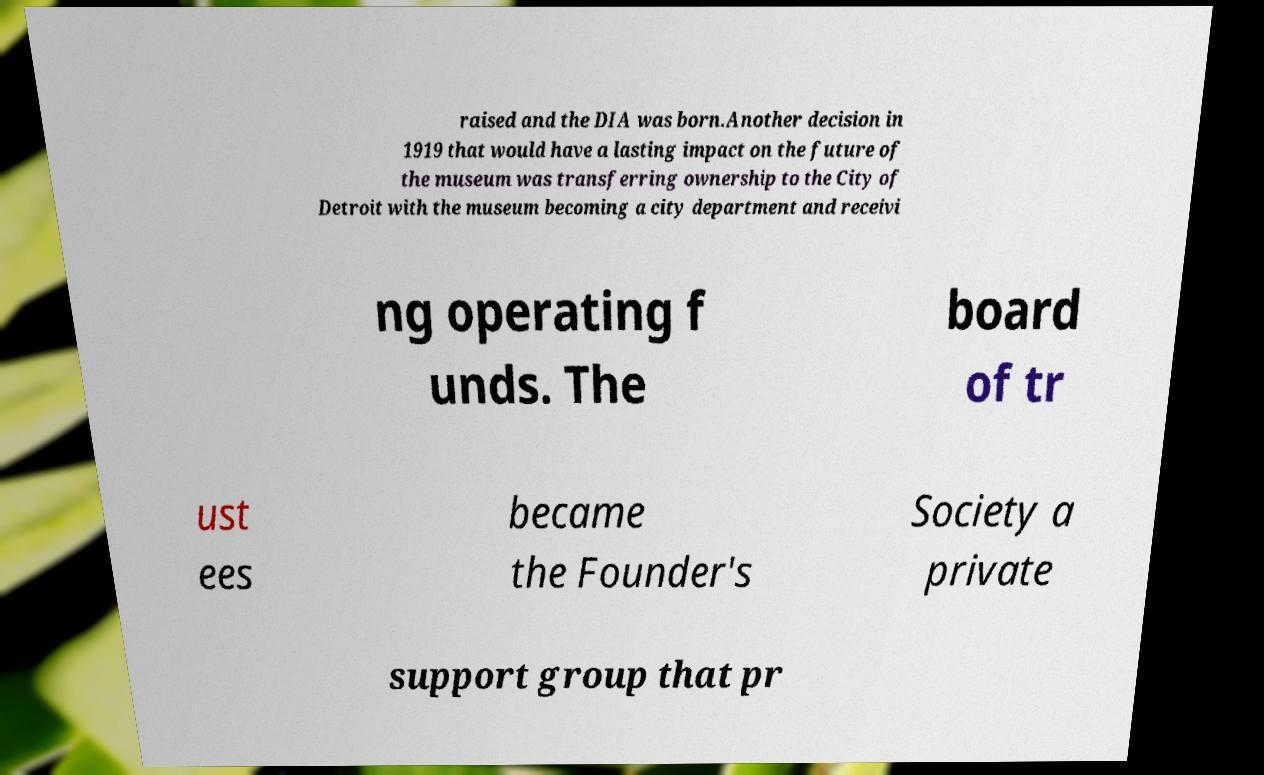Can you read and provide the text displayed in the image?This photo seems to have some interesting text. Can you extract and type it out for me? raised and the DIA was born.Another decision in 1919 that would have a lasting impact on the future of the museum was transferring ownership to the City of Detroit with the museum becoming a city department and receivi ng operating f unds. The board of tr ust ees became the Founder's Society a private support group that pr 